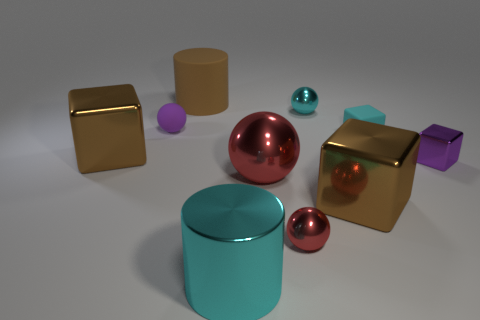What number of spheres have the same color as the big rubber object?
Provide a succinct answer. 0. How many objects are tiny purple shiny cubes or large cylinders that are on the left side of the big cyan metal object?
Give a very brief answer. 2. Do the metallic object left of the big cyan thing and the purple thing that is on the left side of the cyan metallic cylinder have the same size?
Give a very brief answer. No. Are there any blue cylinders that have the same material as the small cyan cube?
Provide a short and direct response. No. What is the shape of the large red metallic object?
Offer a terse response. Sphere. What shape is the cyan metal thing behind the red ball that is to the left of the tiny red metal object?
Your answer should be very brief. Sphere. What number of other things are the same shape as the tiny red shiny thing?
Keep it short and to the point. 3. There is a brown block right of the small cyan object behind the purple matte sphere; how big is it?
Offer a very short reply. Large. Are any small brown cylinders visible?
Ensure brevity in your answer.  No. What number of things are on the left side of the cylinder in front of the tiny cyan sphere?
Keep it short and to the point. 3. 